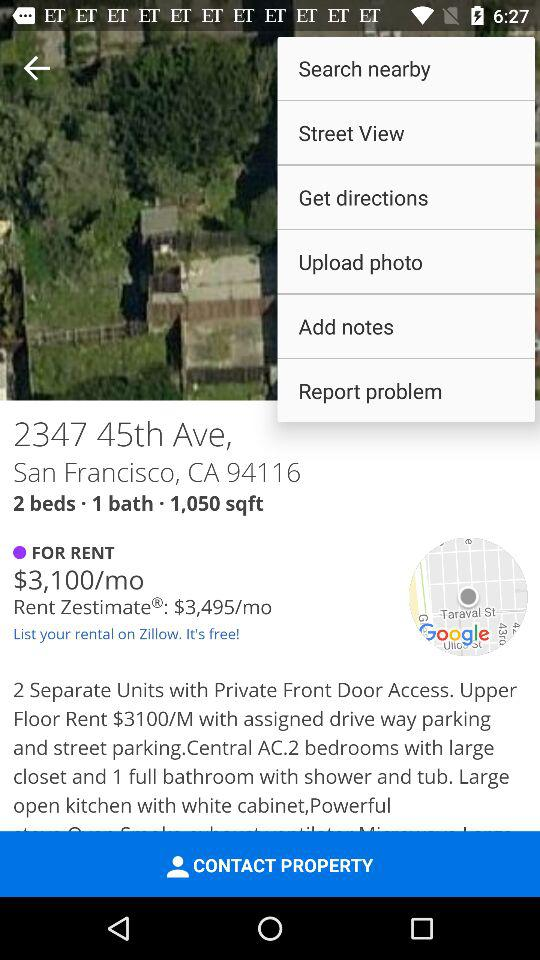Are pets allowed in the listing?
When the provided information is insufficient, respond with <no answer>. <no answer> 